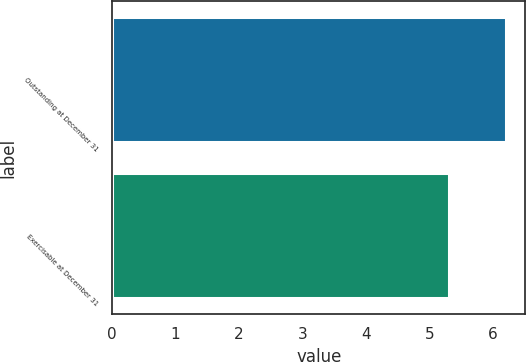<chart> <loc_0><loc_0><loc_500><loc_500><bar_chart><fcel>Outstanding at December 31<fcel>Exercisable at December 31<nl><fcel>6.2<fcel>5.3<nl></chart> 